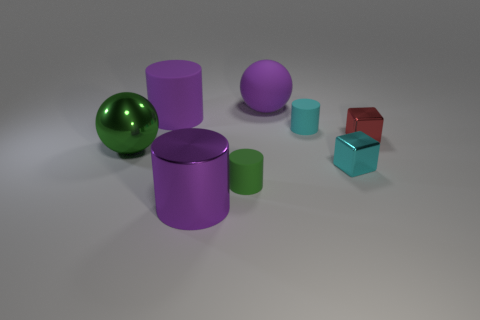Subtract all large shiny cylinders. How many cylinders are left? 3 Add 2 small red objects. How many objects exist? 10 Subtract all green cylinders. How many cylinders are left? 3 Subtract 1 spheres. How many spheres are left? 1 Subtract all purple cylinders. How many gray blocks are left? 0 Subtract all blue blocks. Subtract all purple cylinders. How many blocks are left? 2 Subtract all tiny yellow things. Subtract all small cyan matte things. How many objects are left? 7 Add 7 cyan cylinders. How many cyan cylinders are left? 8 Add 6 cyan cylinders. How many cyan cylinders exist? 7 Subtract 1 purple balls. How many objects are left? 7 